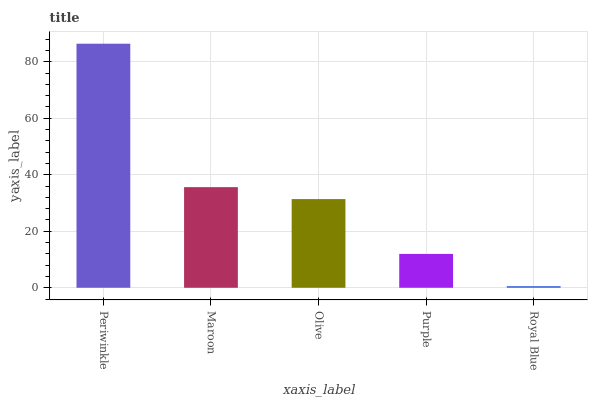Is Royal Blue the minimum?
Answer yes or no. Yes. Is Periwinkle the maximum?
Answer yes or no. Yes. Is Maroon the minimum?
Answer yes or no. No. Is Maroon the maximum?
Answer yes or no. No. Is Periwinkle greater than Maroon?
Answer yes or no. Yes. Is Maroon less than Periwinkle?
Answer yes or no. Yes. Is Maroon greater than Periwinkle?
Answer yes or no. No. Is Periwinkle less than Maroon?
Answer yes or no. No. Is Olive the high median?
Answer yes or no. Yes. Is Olive the low median?
Answer yes or no. Yes. Is Purple the high median?
Answer yes or no. No. Is Periwinkle the low median?
Answer yes or no. No. 